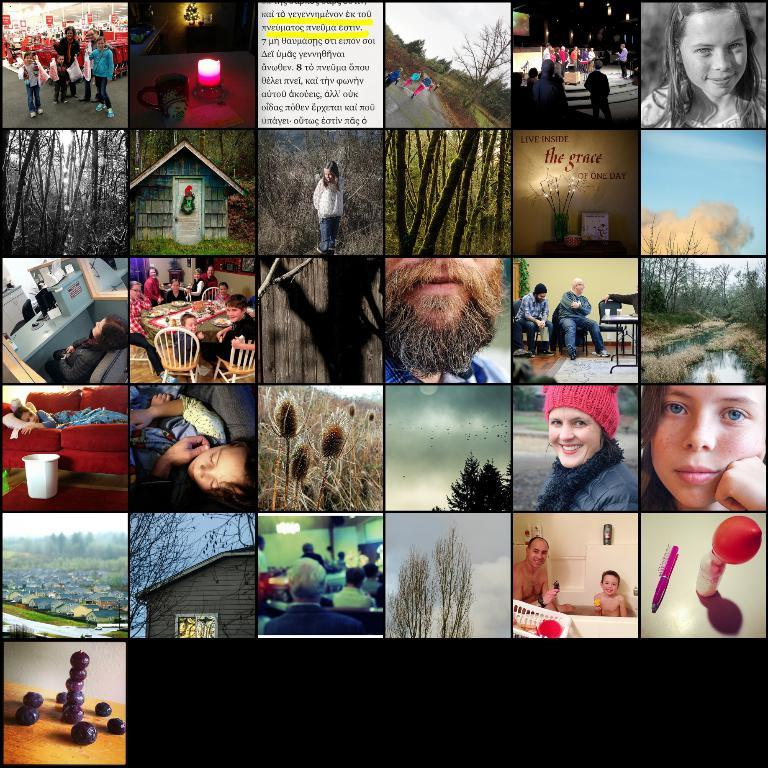What type of visual composition is present in the image? The image contains a collage of photographs. Can you describe the arrangement of the photographs in the collage? Unfortunately, the arrangement of the photographs cannot be determined from the given fact. What subjects or themes might be depicted in the photographs? The subjects or themes of the photographs cannot be determined from the given fact. What type of bridge can be seen in the image? There is no bridge present in the image; it contains a collage of photographs. How many knives are visible in the image? There is no knife present in the image; it contains a collage of photographs. 